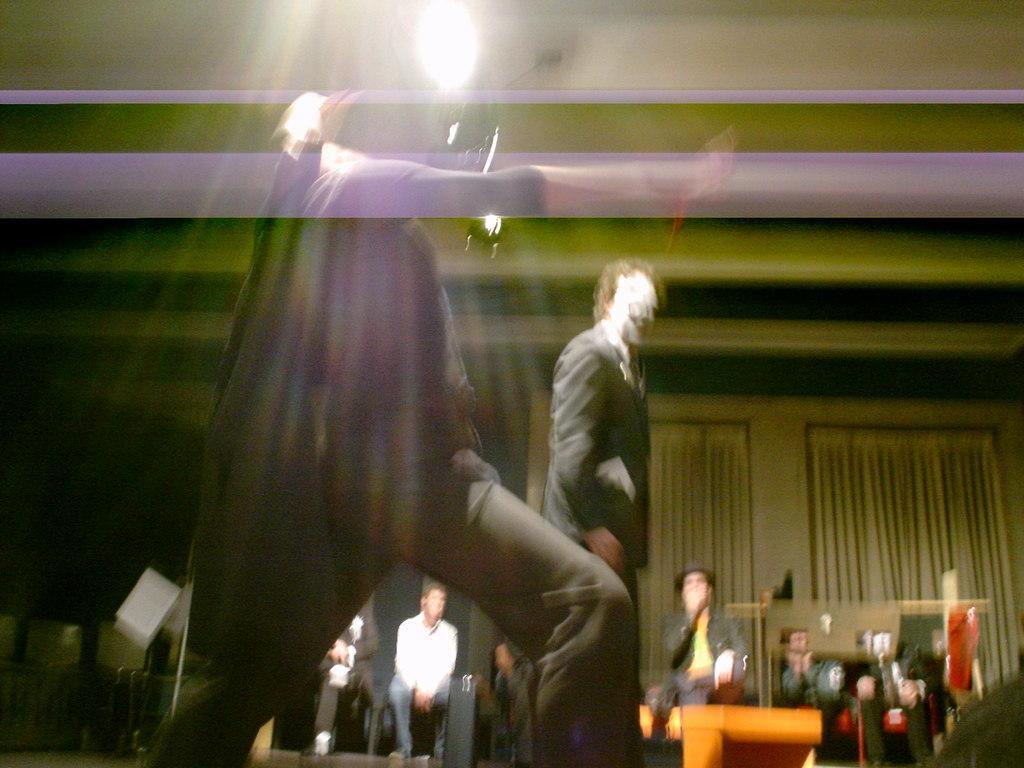Can you describe this image briefly? In the picture I can see blur image, some people are walking and some people are sitting, we can see light to the roof. 